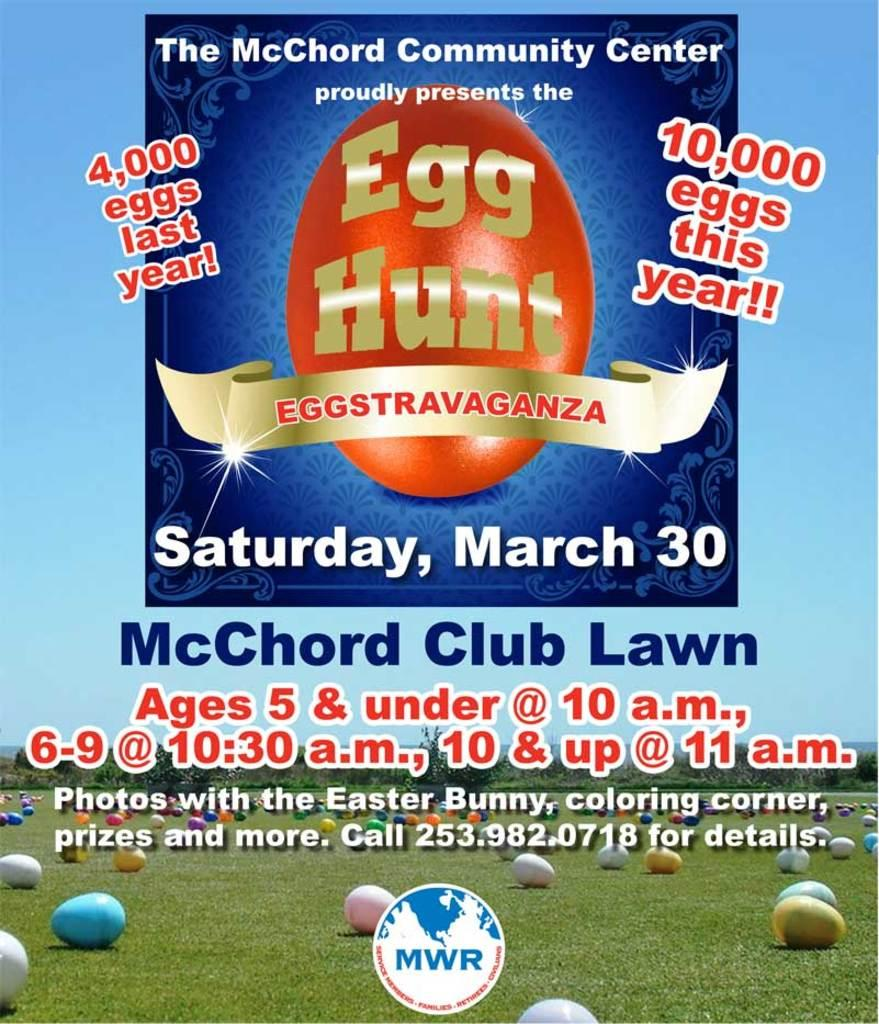Provide a one-sentence caption for the provided image. An Egg hunt is advertised for March 30th. 